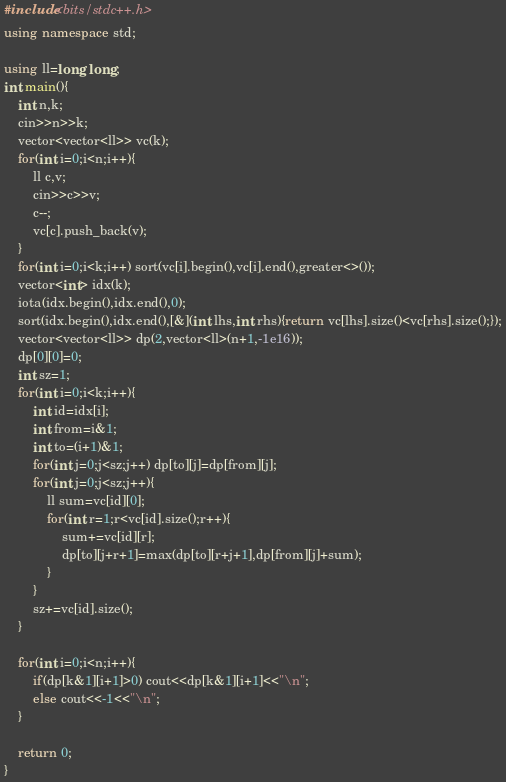Convert code to text. <code><loc_0><loc_0><loc_500><loc_500><_C++_>#include<bits/stdc++.h>
using namespace std;

using ll=long long;
int main(){
    int n,k;
    cin>>n>>k;
    vector<vector<ll>> vc(k);
    for(int i=0;i<n;i++){
        ll c,v;
        cin>>c>>v;
        c--;
        vc[c].push_back(v);
    }
    for(int i=0;i<k;i++) sort(vc[i].begin(),vc[i].end(),greater<>());
    vector<int> idx(k);
    iota(idx.begin(),idx.end(),0);
    sort(idx.begin(),idx.end(),[&](int lhs,int rhs){return vc[lhs].size()<vc[rhs].size();});
    vector<vector<ll>> dp(2,vector<ll>(n+1,-1e16));
    dp[0][0]=0;
    int sz=1;
    for(int i=0;i<k;i++){
        int id=idx[i];
        int from=i&1;
        int to=(i+1)&1;
        for(int j=0;j<sz;j++) dp[to][j]=dp[from][j];
        for(int j=0;j<sz;j++){
            ll sum=vc[id][0];
            for(int r=1;r<vc[id].size();r++){
                sum+=vc[id][r];
                dp[to][j+r+1]=max(dp[to][r+j+1],dp[from][j]+sum);
            }
        }
        sz+=vc[id].size();
    }
    
    for(int i=0;i<n;i++){
        if(dp[k&1][i+1]>0) cout<<dp[k&1][i+1]<<"\n";
        else cout<<-1<<"\n";
    }

    return 0;
}</code> 